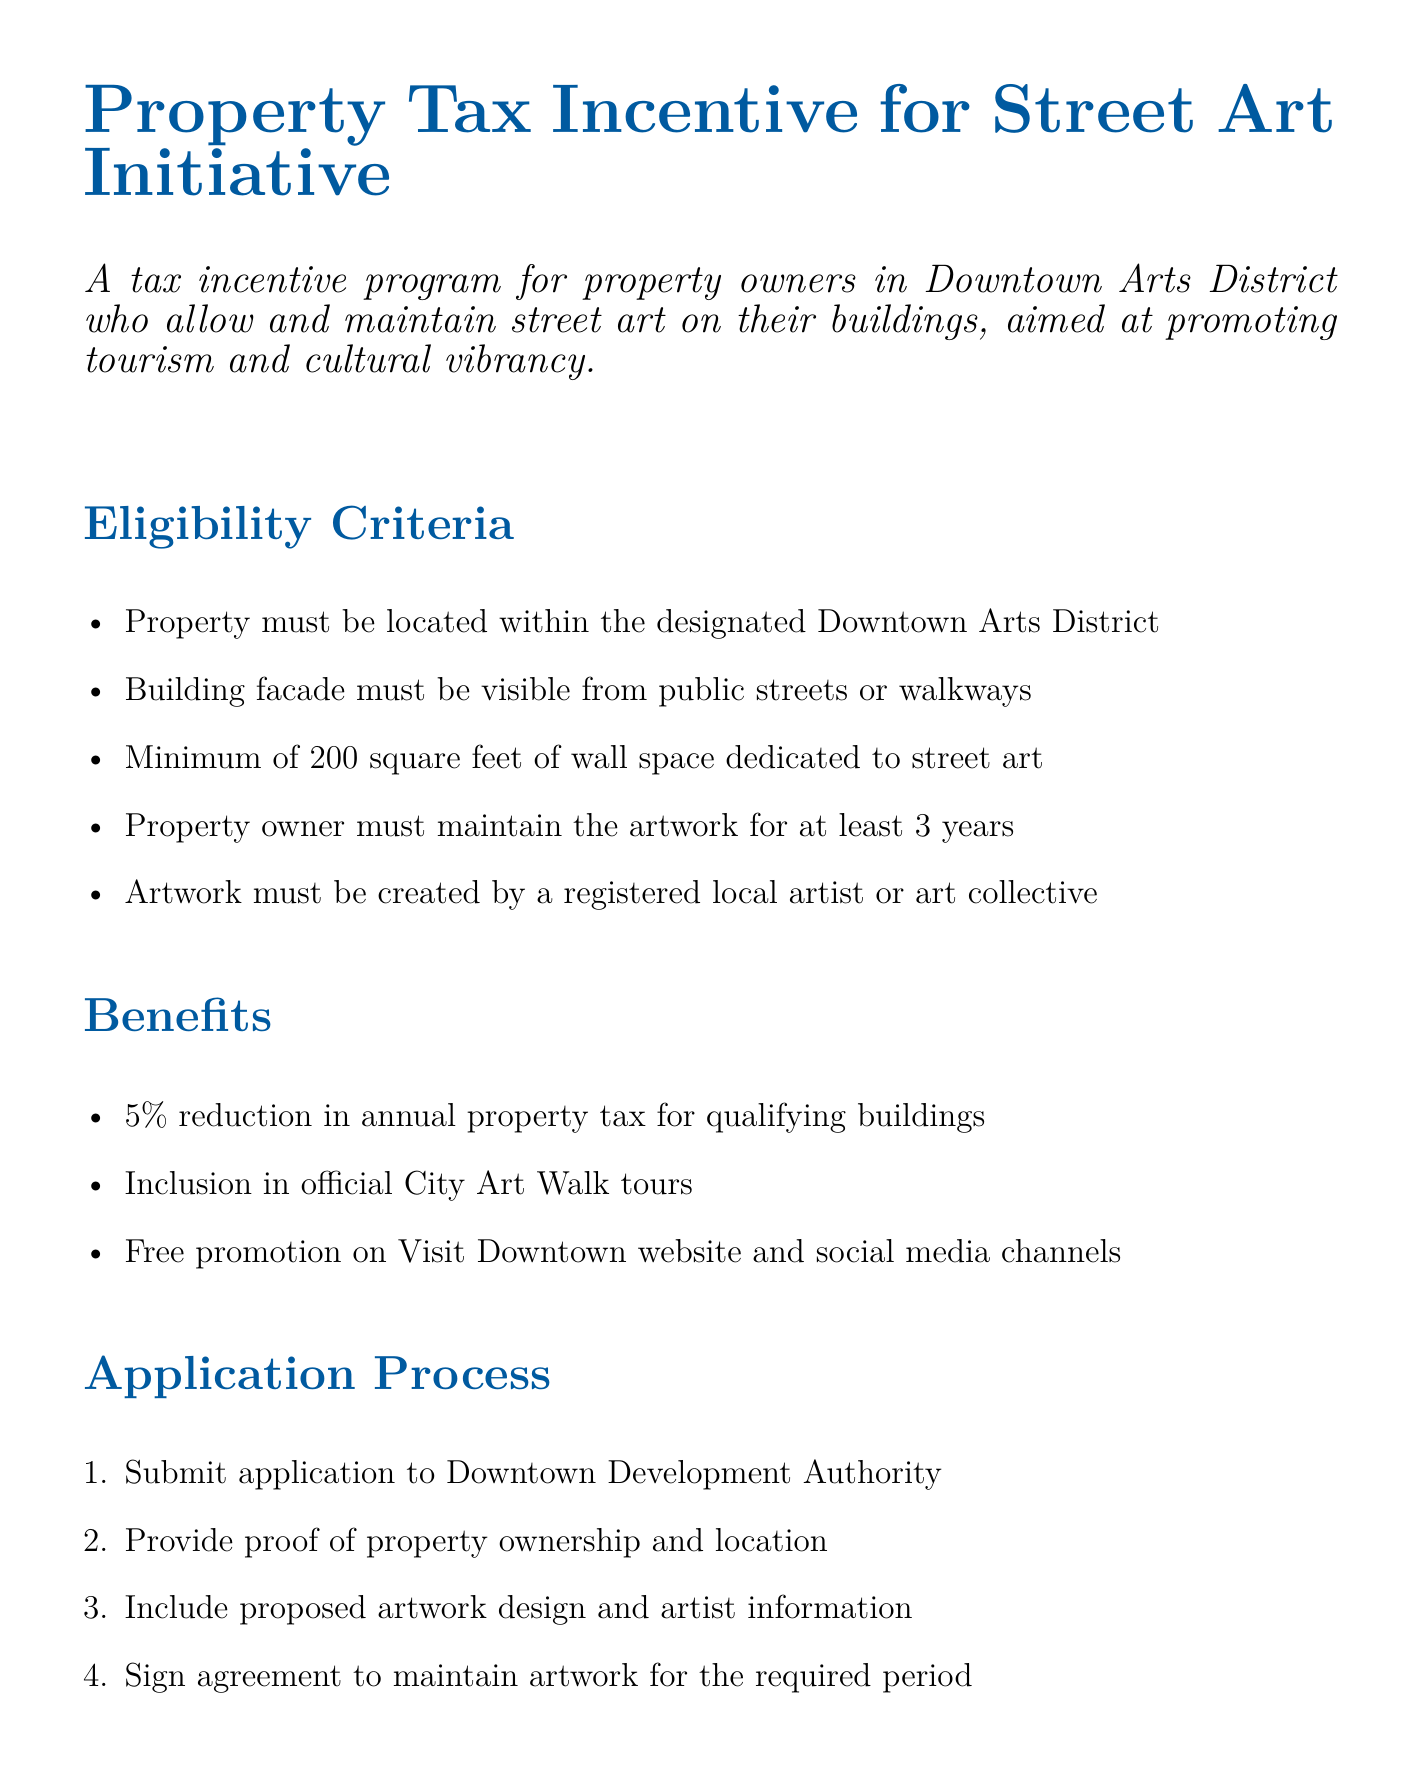What is the minimum wall space for street art? The minimum wall space must be 200 square feet dedicated to street art, according to the eligibility criteria.
Answer: 200 square feet Who reviews and approves all applications? The Downtown Arts Commission is responsible for reviewing and approving all applications specified in the program details.
Answer: Downtown Arts Commission What is the property tax reduction offered? The document states that there is a 5% reduction in annual property tax for qualifying buildings.
Answer: 5% How long must property owners maintain the artwork? The eligibility criteria require that property owners must maintain the artwork for at least 3 years.
Answer: 3 years What is the total annual allocation for funding this initiative? The funding source section mentions an allocation of $500,000 annually for the program.
Answer: $500,000 What is included in the official City Art Walk tours? Qualifying buildings that allow street art are included in the official City Art Walk tours, as mentioned under benefits.
Answer: Inclusion in official City Art Walk tours What is the expected increase in foot traffic to Downtown Arts District? The expected outcomes section indicates that there will be a 20% increase in foot traffic to the Downtown Arts District.
Answer: 20% What must property owners submit with their application? Property owners must include proposed artwork design and artist information as part of their application.
Answer: Proposed artwork design and artist information 